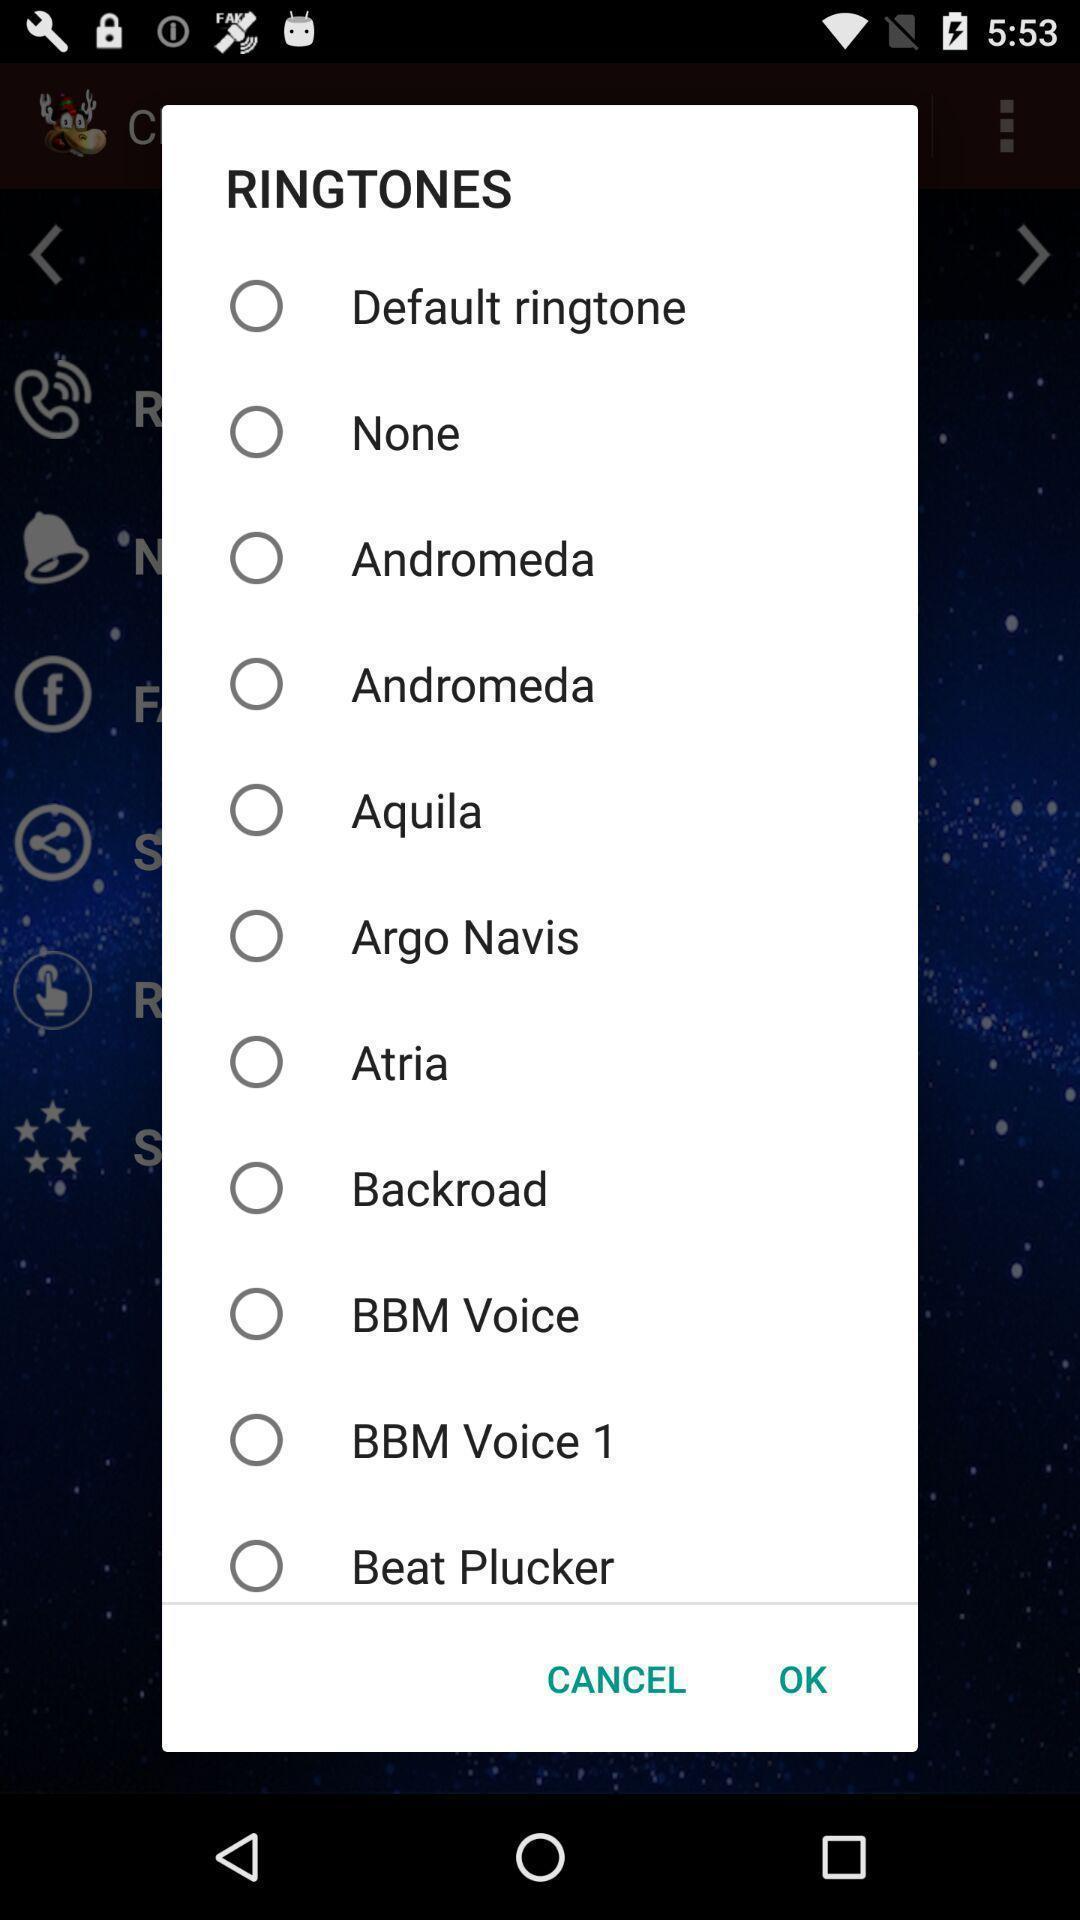What details can you identify in this image? Pop-up to select ringtones. 